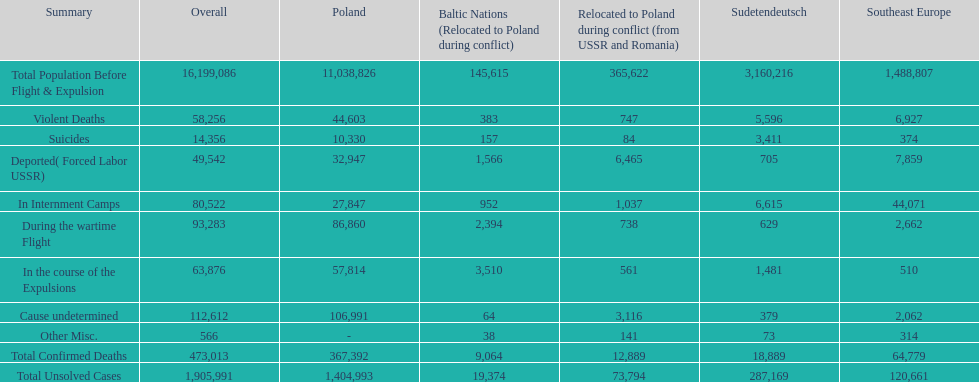Which region had the least total of unsolved cases? Baltic States(Resettled in Poland during war). 